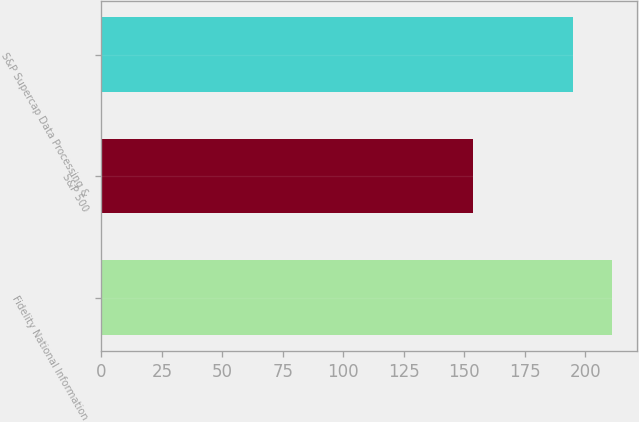Convert chart to OTSL. <chart><loc_0><loc_0><loc_500><loc_500><bar_chart><fcel>Fidelity National Information<fcel>S&P 500<fcel>S&P Supercap Data Processing &<nl><fcel>210.97<fcel>153.58<fcel>194.91<nl></chart> 